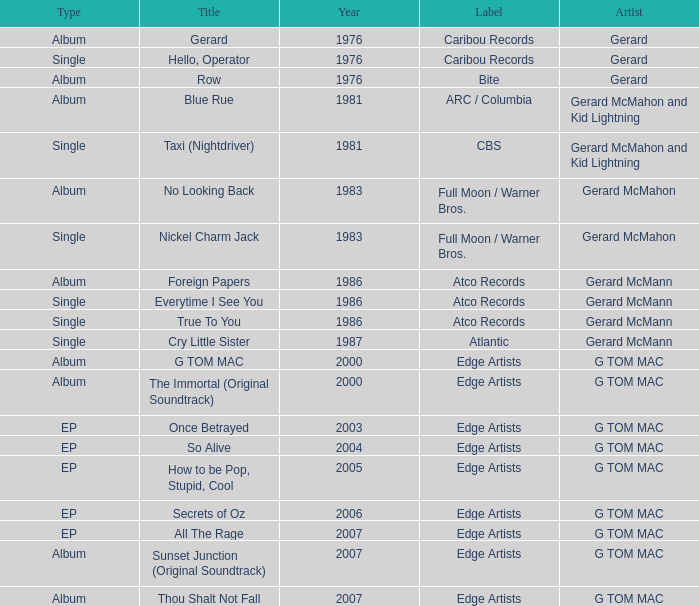Which Title has a Type of ep and a Year larger than 2003? So Alive, How to be Pop, Stupid, Cool, Secrets of Oz, All The Rage. 